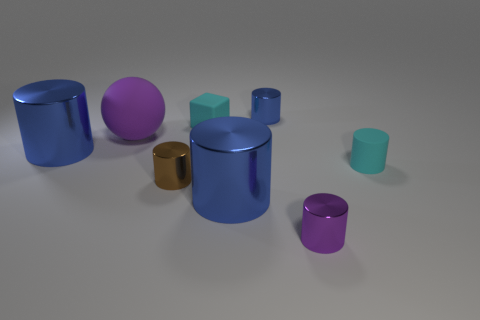Subtract all tiny cyan rubber cylinders. How many cylinders are left? 5 Subtract all purple cylinders. How many cylinders are left? 5 Add 1 small yellow metal cubes. How many objects exist? 9 Subtract all green balls. How many blue cylinders are left? 3 Add 8 small red metal balls. How many small red metal balls exist? 8 Subtract 0 gray balls. How many objects are left? 8 Subtract all cylinders. How many objects are left? 2 Subtract 1 blocks. How many blocks are left? 0 Subtract all cyan balls. Subtract all blue cubes. How many balls are left? 1 Subtract all brown metallic cylinders. Subtract all tiny purple things. How many objects are left? 6 